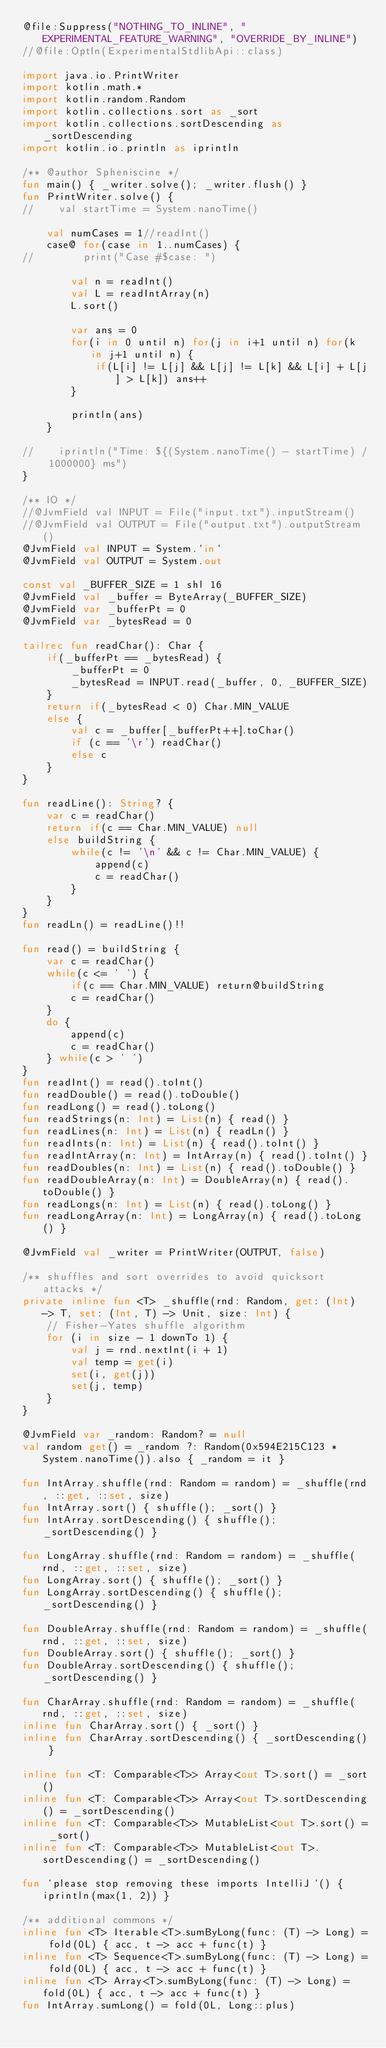<code> <loc_0><loc_0><loc_500><loc_500><_Kotlin_>@file:Suppress("NOTHING_TO_INLINE", "EXPERIMENTAL_FEATURE_WARNING", "OVERRIDE_BY_INLINE")
//@file:OptIn(ExperimentalStdlibApi::class)

import java.io.PrintWriter
import kotlin.math.*
import kotlin.random.Random
import kotlin.collections.sort as _sort
import kotlin.collections.sortDescending as _sortDescending
import kotlin.io.println as iprintln

/** @author Spheniscine */
fun main() { _writer.solve(); _writer.flush() }
fun PrintWriter.solve() {
//    val startTime = System.nanoTime()

    val numCases = 1//readInt()
    case@ for(case in 1..numCases) {
//        print("Case #$case: ")

        val n = readInt()
        val L = readIntArray(n)
        L.sort()

        var ans = 0
        for(i in 0 until n) for(j in i+1 until n) for(k in j+1 until n) {
            if(L[i] != L[j] && L[j] != L[k] && L[i] + L[j] > L[k]) ans++
        }

        println(ans)
    }

//    iprintln("Time: ${(System.nanoTime() - startTime) / 1000000} ms")
}

/** IO */
//@JvmField val INPUT = File("input.txt").inputStream()
//@JvmField val OUTPUT = File("output.txt").outputStream()
@JvmField val INPUT = System.`in`
@JvmField val OUTPUT = System.out

const val _BUFFER_SIZE = 1 shl 16
@JvmField val _buffer = ByteArray(_BUFFER_SIZE)
@JvmField var _bufferPt = 0
@JvmField var _bytesRead = 0

tailrec fun readChar(): Char {
    if(_bufferPt == _bytesRead) {
        _bufferPt = 0
        _bytesRead = INPUT.read(_buffer, 0, _BUFFER_SIZE)
    }
    return if(_bytesRead < 0) Char.MIN_VALUE
    else {
        val c = _buffer[_bufferPt++].toChar()
        if (c == '\r') readChar()
        else c
    }
}

fun readLine(): String? {
    var c = readChar()
    return if(c == Char.MIN_VALUE) null
    else buildString {
        while(c != '\n' && c != Char.MIN_VALUE) {
            append(c)
            c = readChar()
        }
    }
}
fun readLn() = readLine()!!

fun read() = buildString {
    var c = readChar()
    while(c <= ' ') {
        if(c == Char.MIN_VALUE) return@buildString
        c = readChar()
    }
    do {
        append(c)
        c = readChar()
    } while(c > ' ')
}
fun readInt() = read().toInt()
fun readDouble() = read().toDouble()
fun readLong() = read().toLong()
fun readStrings(n: Int) = List(n) { read() }
fun readLines(n: Int) = List(n) { readLn() }
fun readInts(n: Int) = List(n) { read().toInt() }
fun readIntArray(n: Int) = IntArray(n) { read().toInt() }
fun readDoubles(n: Int) = List(n) { read().toDouble() }
fun readDoubleArray(n: Int) = DoubleArray(n) { read().toDouble() }
fun readLongs(n: Int) = List(n) { read().toLong() }
fun readLongArray(n: Int) = LongArray(n) { read().toLong() }

@JvmField val _writer = PrintWriter(OUTPUT, false)

/** shuffles and sort overrides to avoid quicksort attacks */
private inline fun <T> _shuffle(rnd: Random, get: (Int) -> T, set: (Int, T) -> Unit, size: Int) {
    // Fisher-Yates shuffle algorithm
    for (i in size - 1 downTo 1) {
        val j = rnd.nextInt(i + 1)
        val temp = get(i)
        set(i, get(j))
        set(j, temp)
    }
}

@JvmField var _random: Random? = null
val random get() = _random ?: Random(0x594E215C123 * System.nanoTime()).also { _random = it }

fun IntArray.shuffle(rnd: Random = random) = _shuffle(rnd, ::get, ::set, size)
fun IntArray.sort() { shuffle(); _sort() }
fun IntArray.sortDescending() { shuffle(); _sortDescending() }

fun LongArray.shuffle(rnd: Random = random) = _shuffle(rnd, ::get, ::set, size)
fun LongArray.sort() { shuffle(); _sort() }
fun LongArray.sortDescending() { shuffle(); _sortDescending() }

fun DoubleArray.shuffle(rnd: Random = random) = _shuffle(rnd, ::get, ::set, size)
fun DoubleArray.sort() { shuffle(); _sort() }
fun DoubleArray.sortDescending() { shuffle(); _sortDescending() }

fun CharArray.shuffle(rnd: Random = random) = _shuffle(rnd, ::get, ::set, size)
inline fun CharArray.sort() { _sort() }
inline fun CharArray.sortDescending() { _sortDescending() }

inline fun <T: Comparable<T>> Array<out T>.sort() = _sort()
inline fun <T: Comparable<T>> Array<out T>.sortDescending() = _sortDescending()
inline fun <T: Comparable<T>> MutableList<out T>.sort() = _sort()
inline fun <T: Comparable<T>> MutableList<out T>.sortDescending() = _sortDescending()

fun `please stop removing these imports IntelliJ`() { iprintln(max(1, 2)) }

/** additional commons */
inline fun <T> Iterable<T>.sumByLong(func: (T) -> Long) = fold(0L) { acc, t -> acc + func(t) }
inline fun <T> Sequence<T>.sumByLong(func: (T) -> Long) = fold(0L) { acc, t -> acc + func(t) }
inline fun <T> Array<T>.sumByLong(func: (T) -> Long) = fold(0L) { acc, t -> acc + func(t) }
fun IntArray.sumLong() = fold(0L, Long::plus)
</code> 